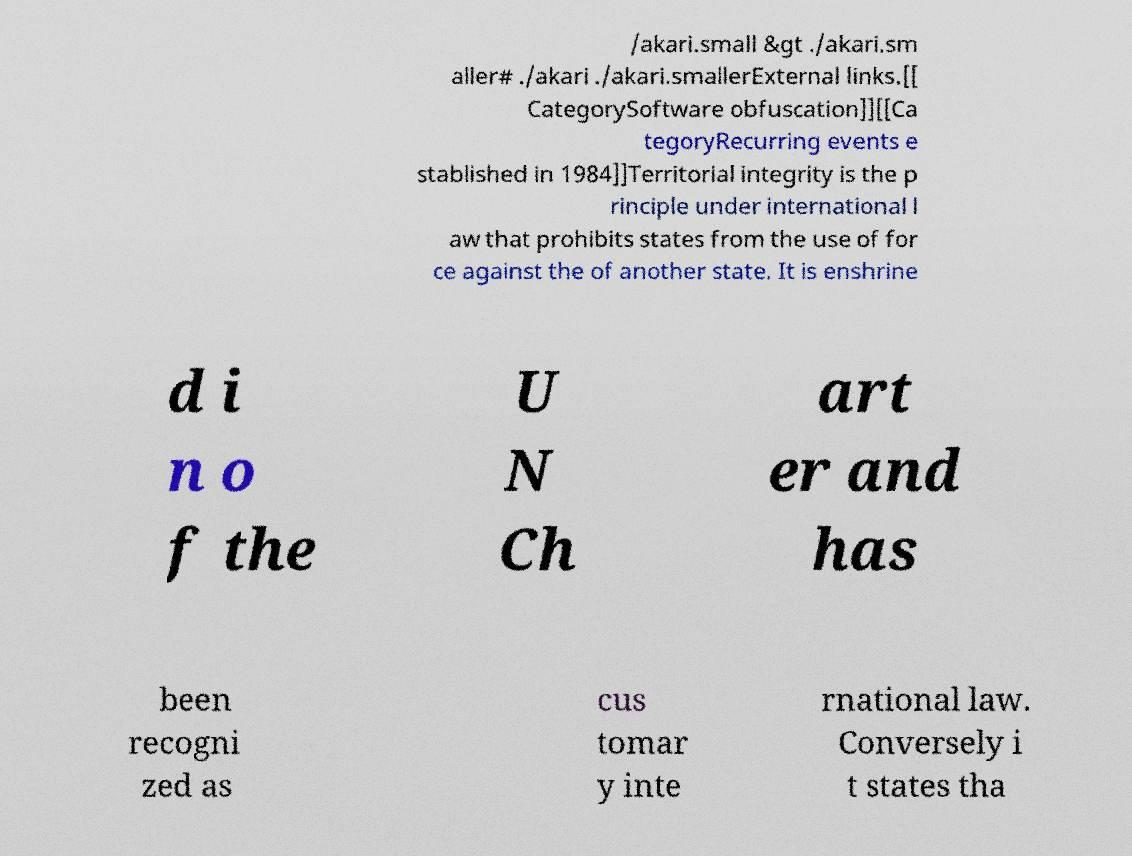There's text embedded in this image that I need extracted. Can you transcribe it verbatim? /akari.small &gt ./akari.sm aller# ./akari ./akari.smallerExternal links.[[ CategorySoftware obfuscation]][[Ca tegoryRecurring events e stablished in 1984]]Territorial integrity is the p rinciple under international l aw that prohibits states from the use of for ce against the of another state. It is enshrine d i n o f the U N Ch art er and has been recogni zed as cus tomar y inte rnational law. Conversely i t states tha 